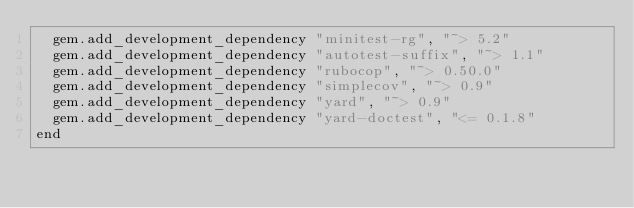Convert code to text. <code><loc_0><loc_0><loc_500><loc_500><_Ruby_>  gem.add_development_dependency "minitest-rg", "~> 5.2"
  gem.add_development_dependency "autotest-suffix", "~> 1.1"
  gem.add_development_dependency "rubocop", "~> 0.50.0"
  gem.add_development_dependency "simplecov", "~> 0.9"
  gem.add_development_dependency "yard", "~> 0.9"
  gem.add_development_dependency "yard-doctest", "<= 0.1.8"
end
</code> 